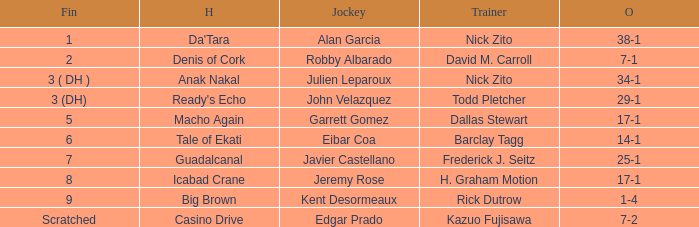Who is the Jockey that has Nick Zito as Trainer and Odds of 34-1? Julien Leparoux. 